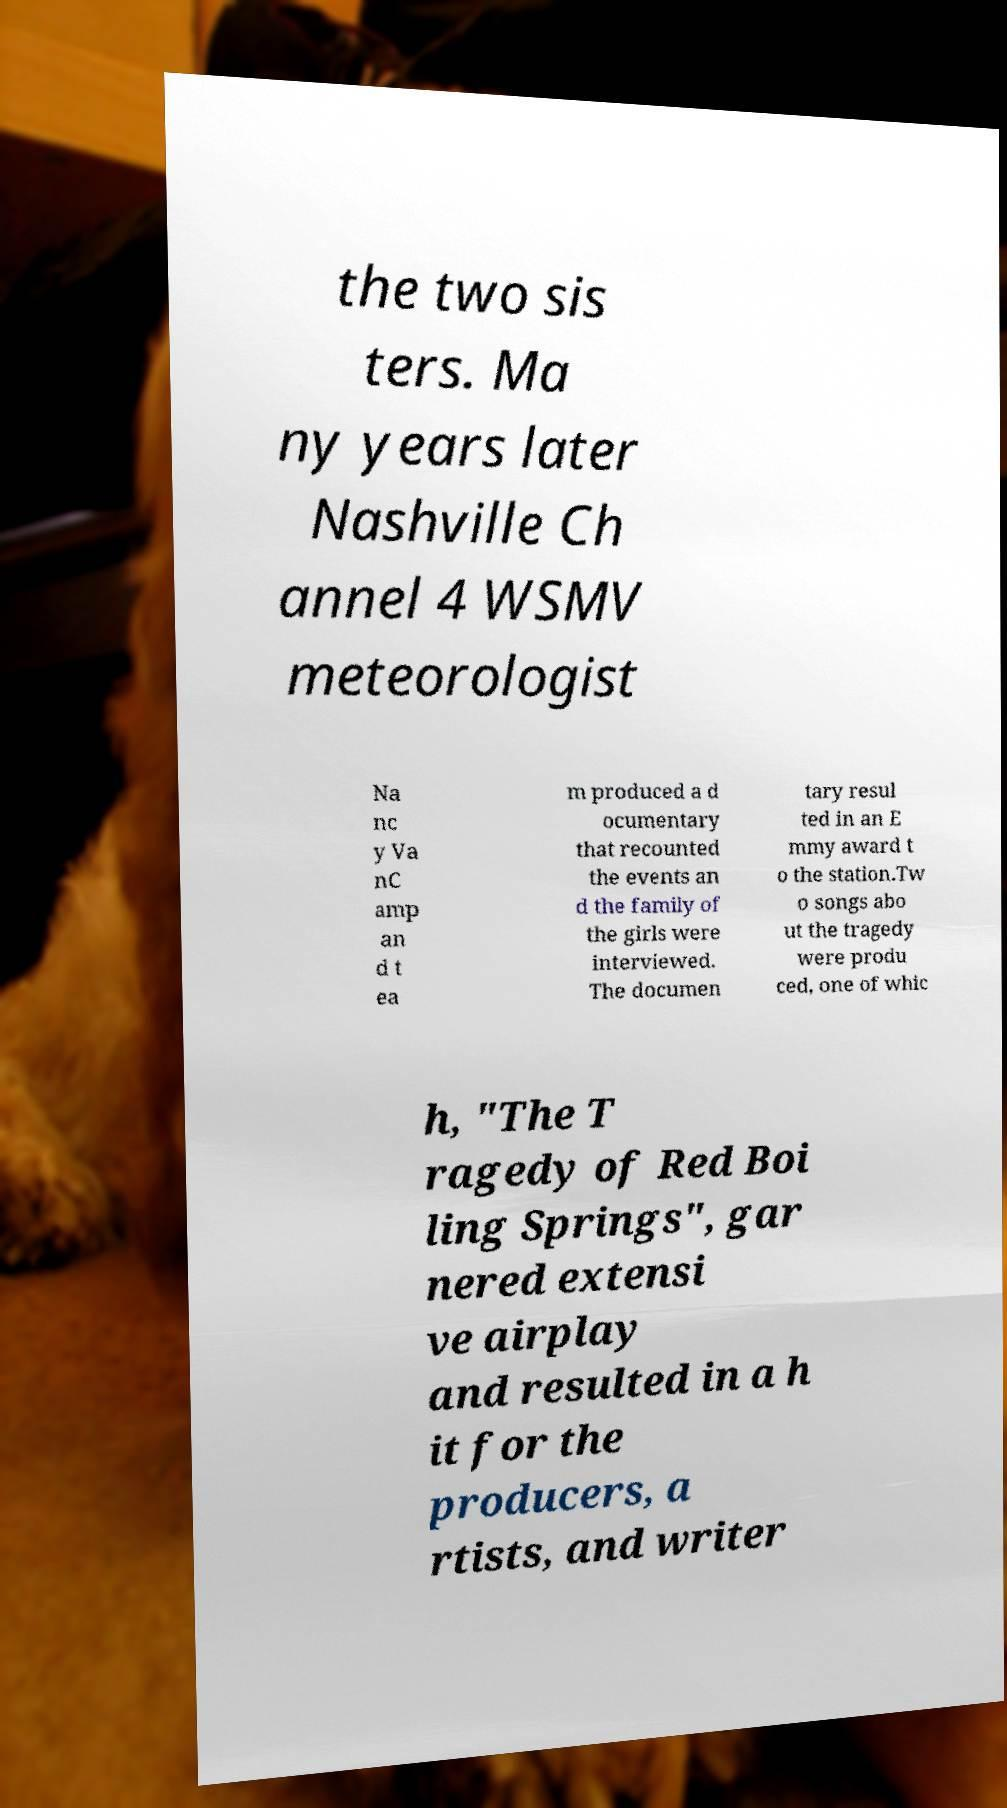I need the written content from this picture converted into text. Can you do that? the two sis ters. Ma ny years later Nashville Ch annel 4 WSMV meteorologist Na nc y Va nC amp an d t ea m produced a d ocumentary that recounted the events an d the family of the girls were interviewed. The documen tary resul ted in an E mmy award t o the station.Tw o songs abo ut the tragedy were produ ced, one of whic h, "The T ragedy of Red Boi ling Springs", gar nered extensi ve airplay and resulted in a h it for the producers, a rtists, and writer 